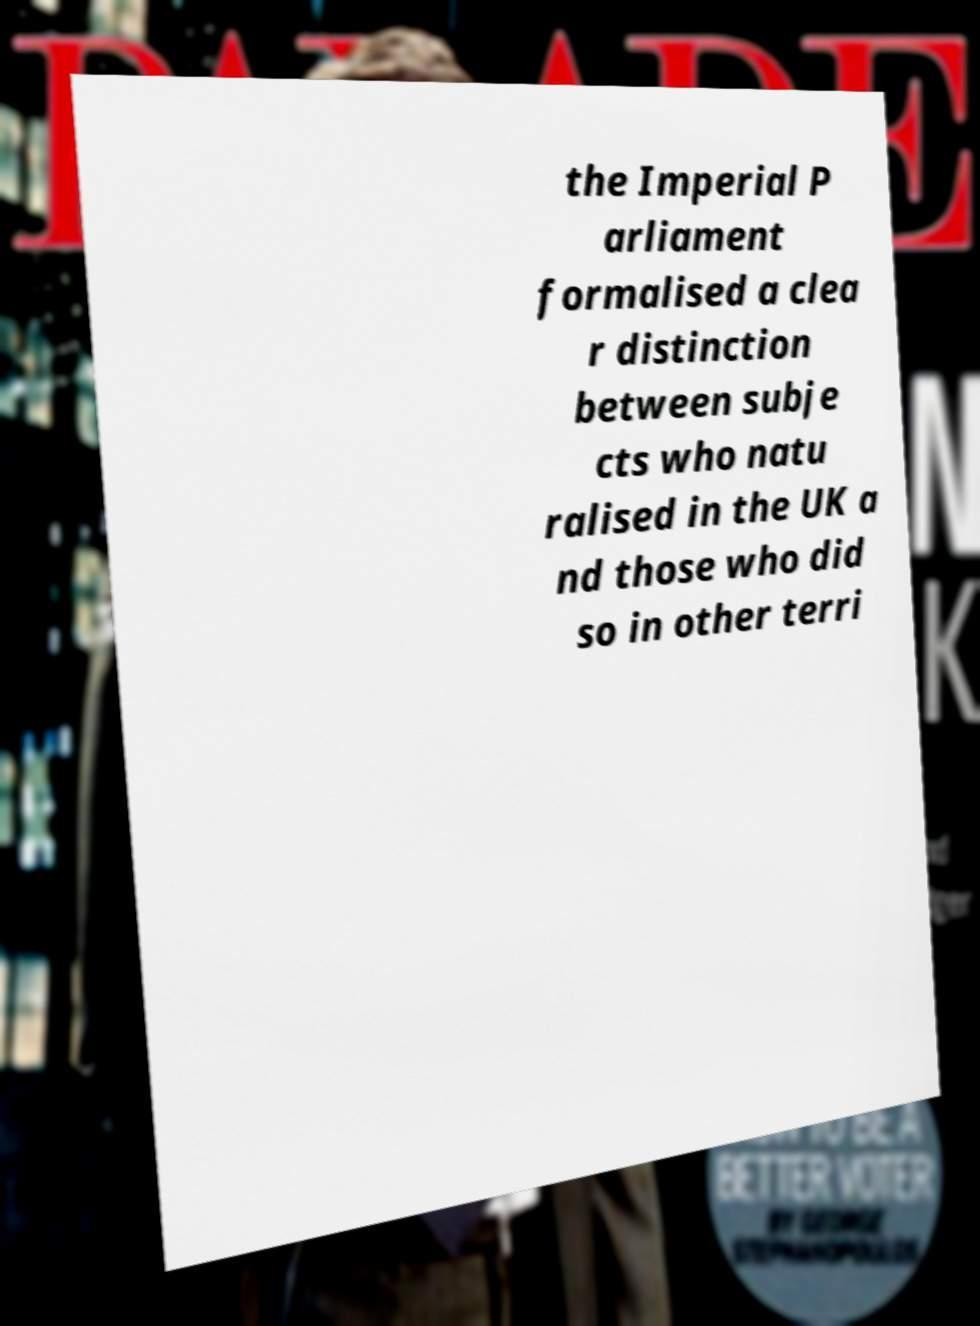Please identify and transcribe the text found in this image. the Imperial P arliament formalised a clea r distinction between subje cts who natu ralised in the UK a nd those who did so in other terri 